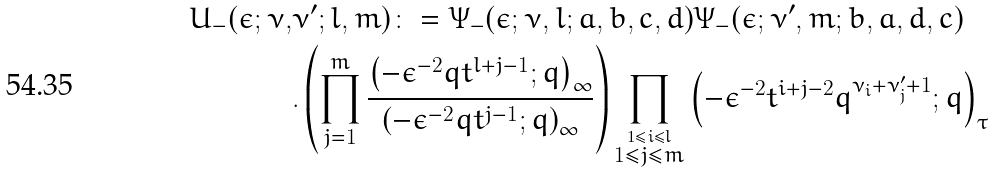<formula> <loc_0><loc_0><loc_500><loc_500>U _ { - } ( \epsilon ; \nu , & \nu ^ { \prime } ; l , m ) \colon = \Psi _ { - } ( \epsilon ; \nu , l ; a , b , c , d ) \Psi _ { - } ( \epsilon ; \nu ^ { \prime } , m ; b , a , d , c ) \\ & . \left ( \prod _ { j = 1 } ^ { m } \frac { \left ( - \epsilon ^ { - 2 } q t ^ { l + j - 1 } ; q \right ) _ { \infty } } { \left ( - \epsilon ^ { - 2 } q t ^ { j - 1 } ; q \right ) _ { \infty } } \right ) \prod _ { \stackrel { 1 \leq i \leq l } { 1 \leq j \leq m } } \left ( - \epsilon ^ { - 2 } t ^ { i + j - 2 } q ^ { \nu _ { i } + \nu _ { j } ^ { \prime } + 1 } ; q \right ) _ { \tau } \\</formula> 